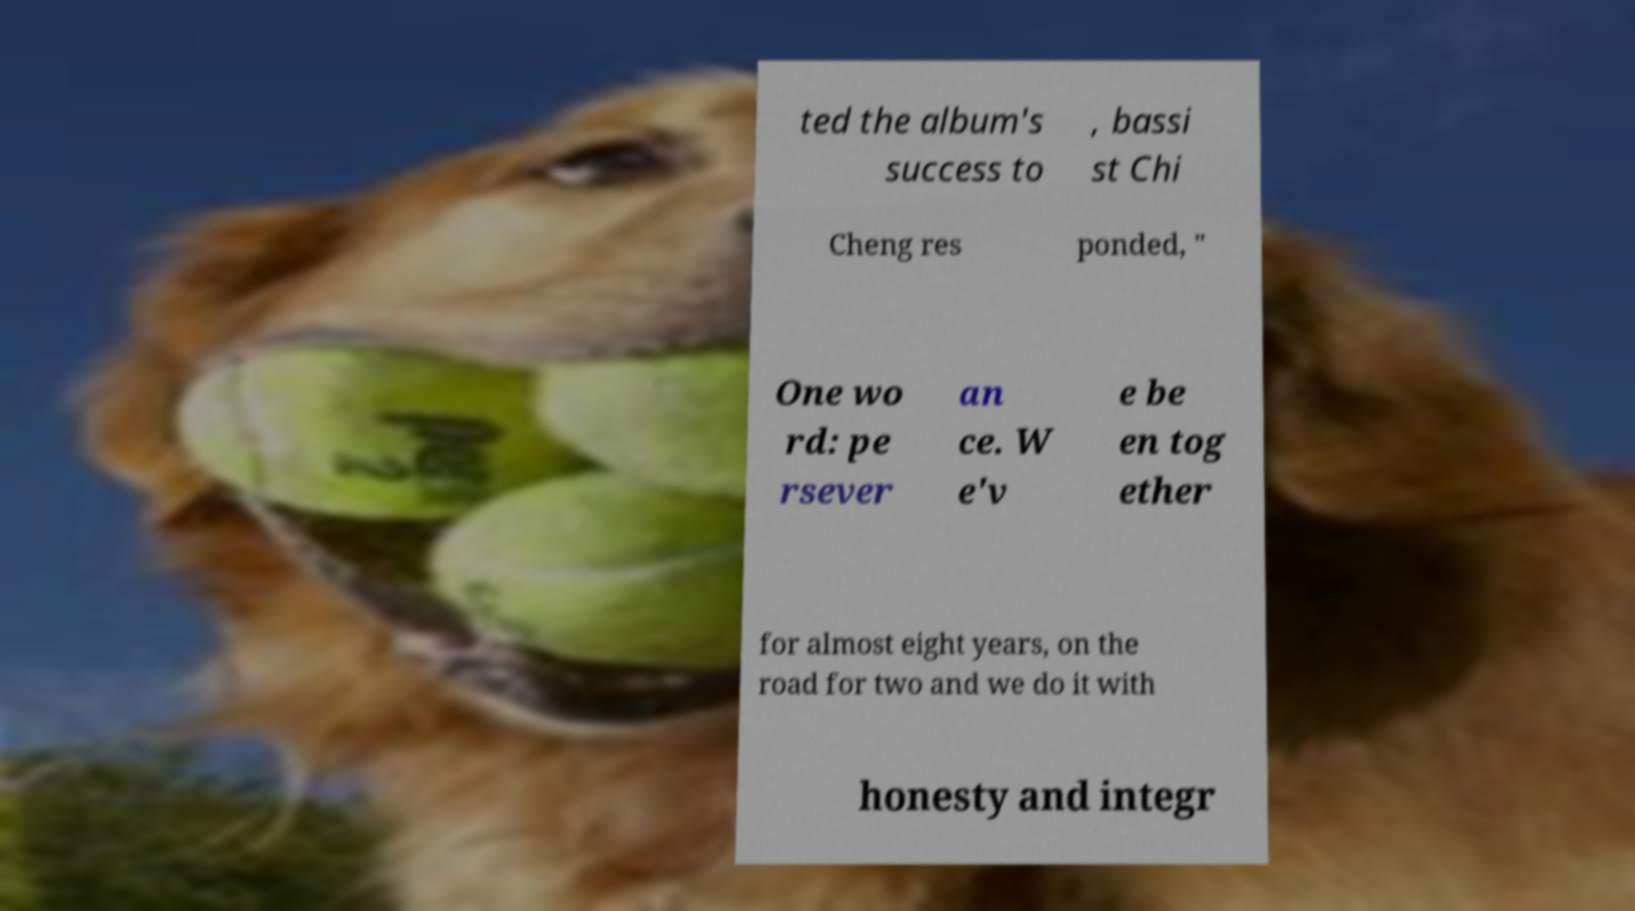Please identify and transcribe the text found in this image. ted the album's success to , bassi st Chi Cheng res ponded, " One wo rd: pe rsever an ce. W e'v e be en tog ether for almost eight years, on the road for two and we do it with honesty and integr 